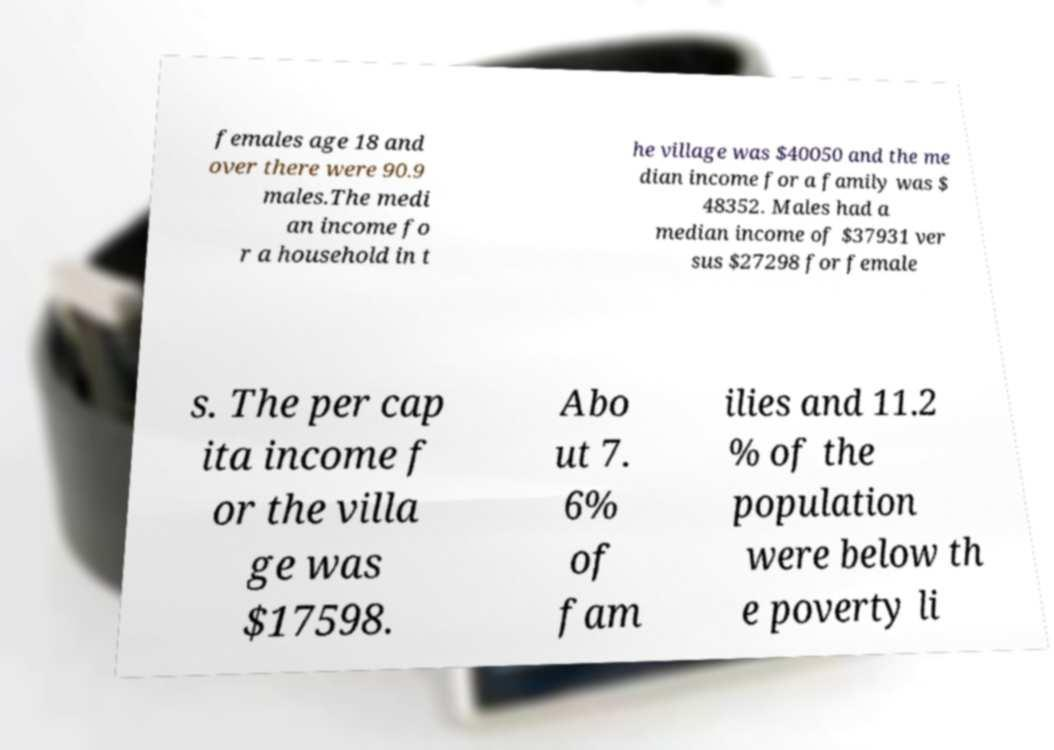Can you read and provide the text displayed in the image?This photo seems to have some interesting text. Can you extract and type it out for me? females age 18 and over there were 90.9 males.The medi an income fo r a household in t he village was $40050 and the me dian income for a family was $ 48352. Males had a median income of $37931 ver sus $27298 for female s. The per cap ita income f or the villa ge was $17598. Abo ut 7. 6% of fam ilies and 11.2 % of the population were below th e poverty li 